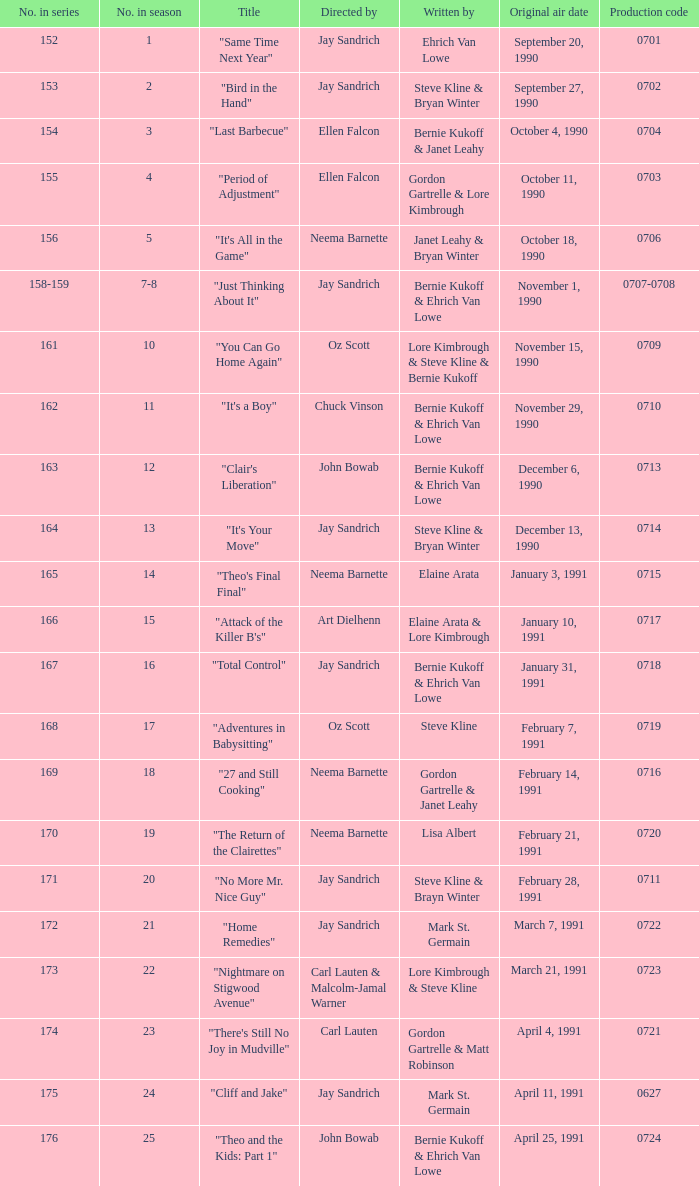The episode directed by art dielhenn was what number in the series?  166.0. 